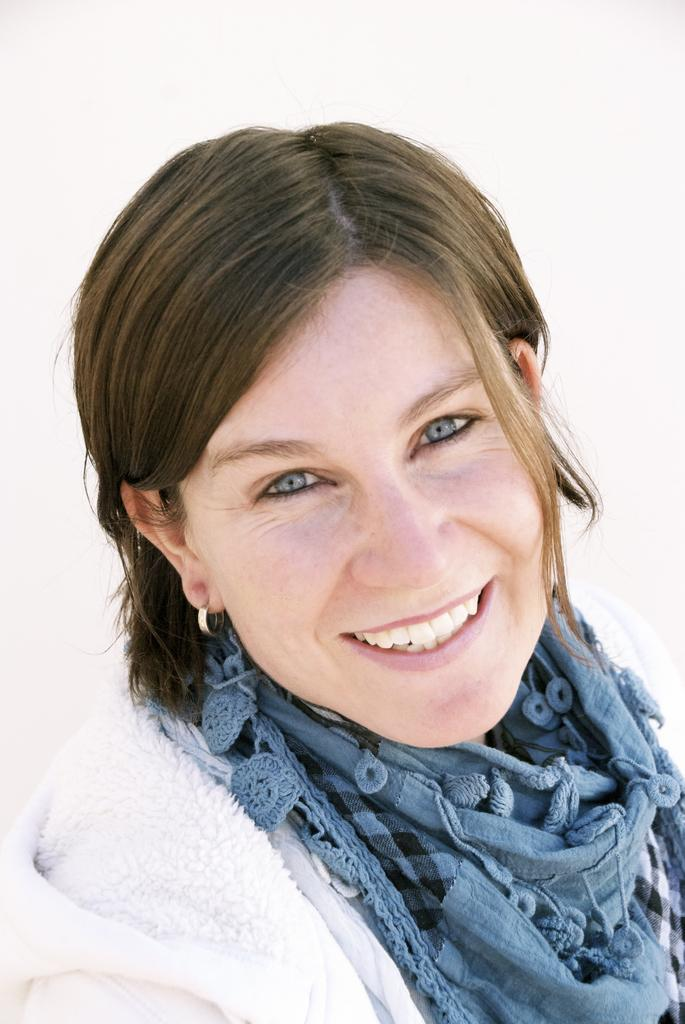Who or what is the main subject in the image? There is a person in the image. What is the person wearing? The person is wearing a white and blue color dress. What color is the background of the image? The background of the image is white. What type of engine can be seen in the image? There is no engine present in the image; it features a person wearing a white and blue color dress against a white background. 